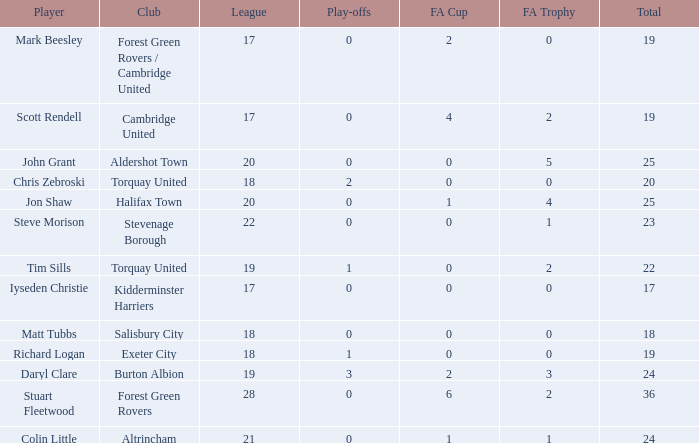Which of the lowest leagues had Aldershot town as a club when the play-offs number was less than 0? None. 